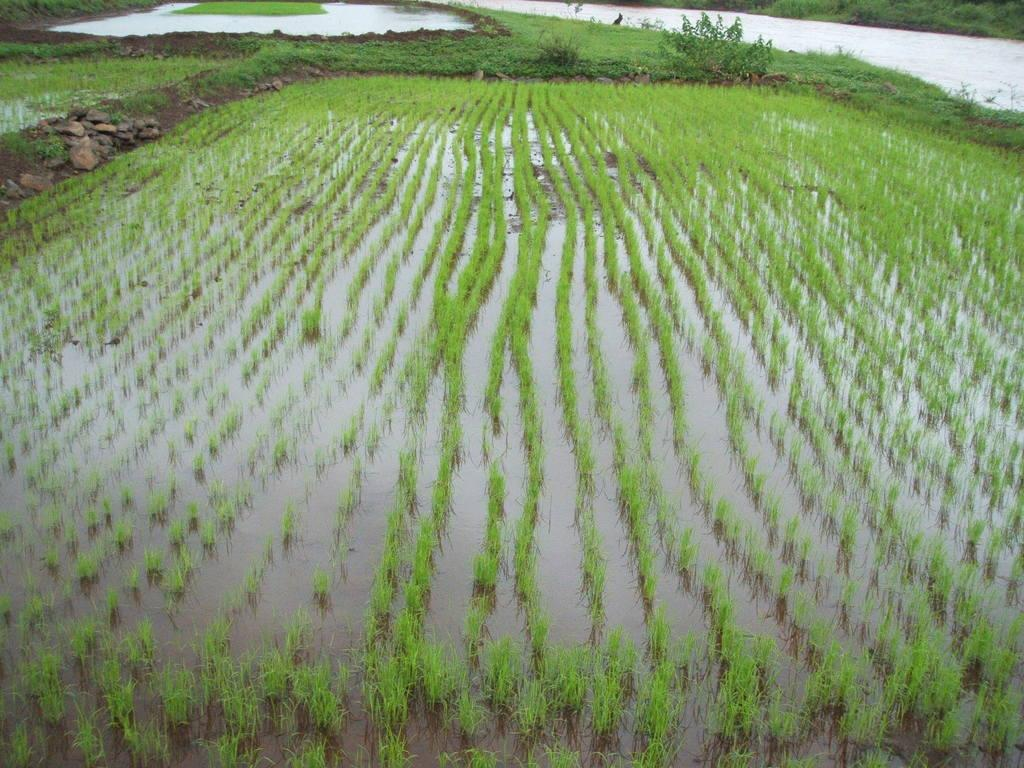What is located at the bottom of the image? There are crops and water at the bottom of the image. What type of vegetation can be seen in the image? There are crops and plants visible in the image. What can be seen in the background of the image? There are plants and water visible in the background of the image. How many lizards are sitting on the crops in the image? There are no lizards present in the image. What type of cattle can be seen grazing in the background of the image? There are no cattle present in the image. 